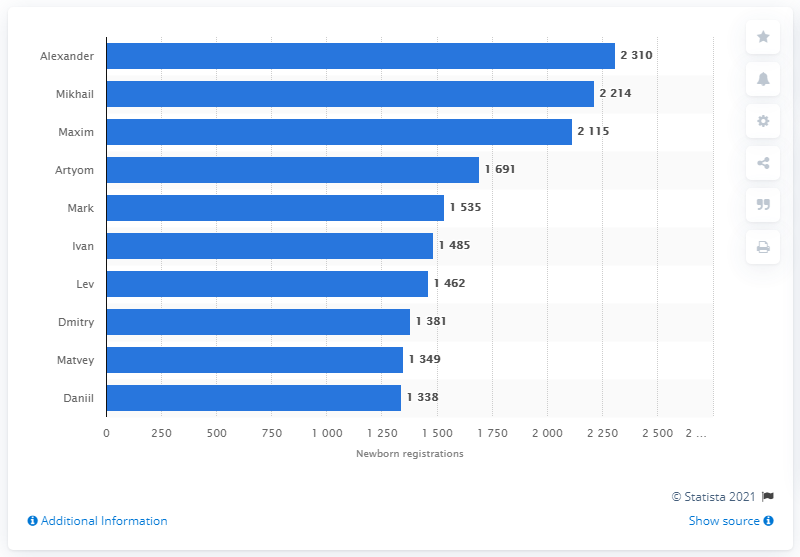Draw attention to some important aspects in this diagram. Alexander is the most common name given to babies in Moscow, as reported by recent studies. Alexander received 2310 name registrations in Moscow from January to November of 2020. Mikhail received 2,214 name registrations. 